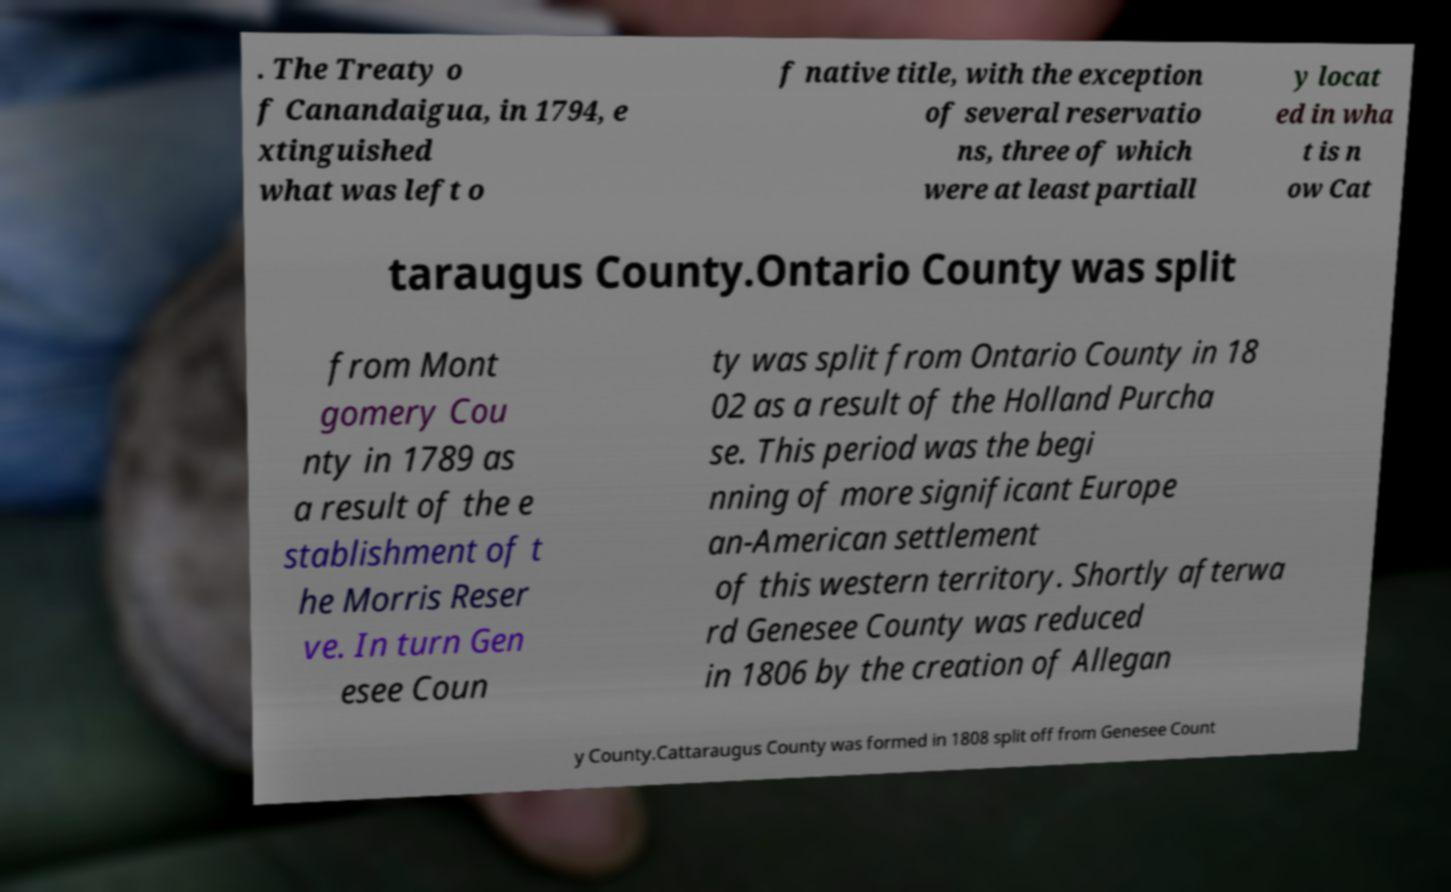Can you read and provide the text displayed in the image?This photo seems to have some interesting text. Can you extract and type it out for me? . The Treaty o f Canandaigua, in 1794, e xtinguished what was left o f native title, with the exception of several reservatio ns, three of which were at least partiall y locat ed in wha t is n ow Cat taraugus County.Ontario County was split from Mont gomery Cou nty in 1789 as a result of the e stablishment of t he Morris Reser ve. In turn Gen esee Coun ty was split from Ontario County in 18 02 as a result of the Holland Purcha se. This period was the begi nning of more significant Europe an-American settlement of this western territory. Shortly afterwa rd Genesee County was reduced in 1806 by the creation of Allegan y County.Cattaraugus County was formed in 1808 split off from Genesee Count 